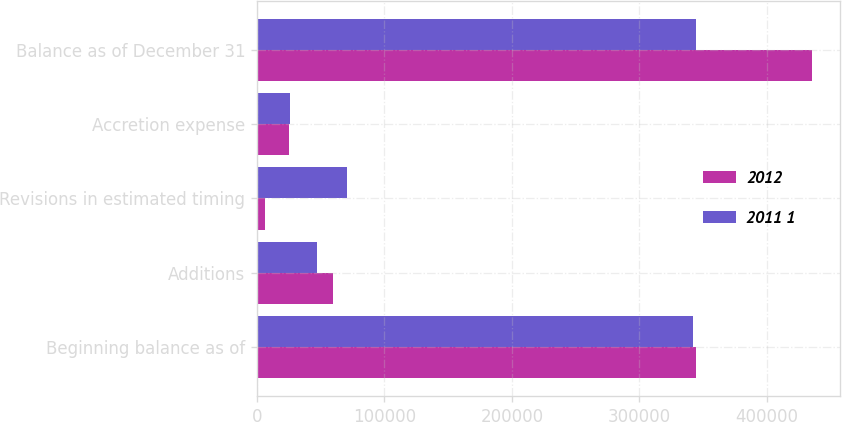Convert chart. <chart><loc_0><loc_0><loc_500><loc_500><stacked_bar_chart><ecel><fcel>Beginning balance as of<fcel>Additions<fcel>Revisions in estimated timing<fcel>Accretion expense<fcel>Balance as of December 31<nl><fcel>2012<fcel>344180<fcel>59847<fcel>6641<fcel>25056<fcel>435724<nl><fcel>2011 1<fcel>341838<fcel>47426<fcel>70755<fcel>25671<fcel>344180<nl></chart> 